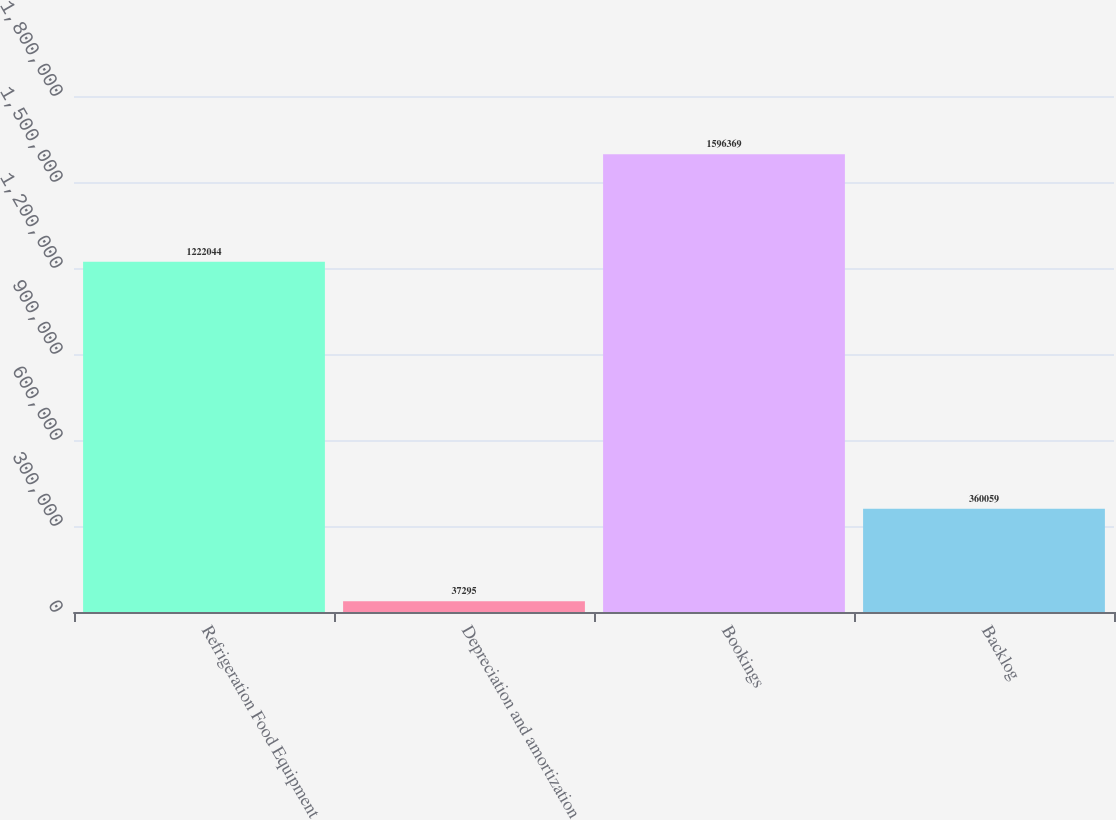Convert chart. <chart><loc_0><loc_0><loc_500><loc_500><bar_chart><fcel>Refrigeration Food Equipment<fcel>Depreciation and amortization<fcel>Bookings<fcel>Backlog<nl><fcel>1.22204e+06<fcel>37295<fcel>1.59637e+06<fcel>360059<nl></chart> 